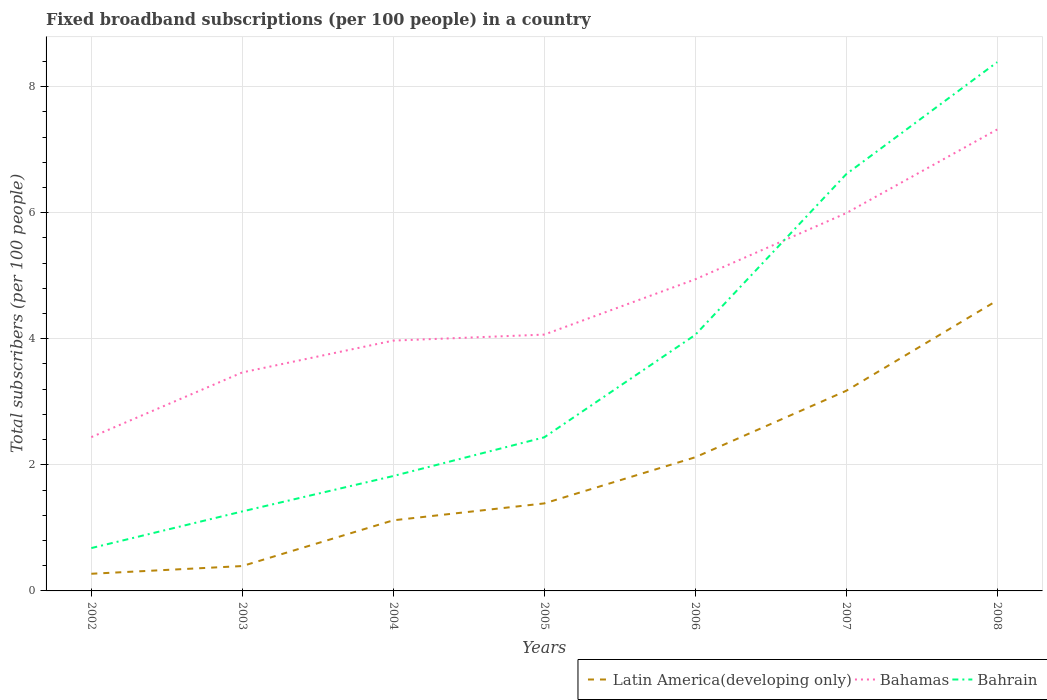Does the line corresponding to Bahrain intersect with the line corresponding to Latin America(developing only)?
Make the answer very short. No. Is the number of lines equal to the number of legend labels?
Keep it short and to the point. Yes. Across all years, what is the maximum number of broadband subscriptions in Bahamas?
Your response must be concise. 2.44. In which year was the number of broadband subscriptions in Bahamas maximum?
Your answer should be very brief. 2002. What is the total number of broadband subscriptions in Bahrain in the graph?
Keep it short and to the point. -5.95. What is the difference between the highest and the second highest number of broadband subscriptions in Latin America(developing only)?
Provide a short and direct response. 4.34. What is the difference between the highest and the lowest number of broadband subscriptions in Latin America(developing only)?
Offer a very short reply. 3. How many lines are there?
Your answer should be compact. 3. Are the values on the major ticks of Y-axis written in scientific E-notation?
Provide a succinct answer. No. Does the graph contain grids?
Offer a very short reply. Yes. How many legend labels are there?
Provide a short and direct response. 3. How are the legend labels stacked?
Keep it short and to the point. Horizontal. What is the title of the graph?
Give a very brief answer. Fixed broadband subscriptions (per 100 people) in a country. Does "Korea (Democratic)" appear as one of the legend labels in the graph?
Make the answer very short. No. What is the label or title of the Y-axis?
Your answer should be compact. Total subscribers (per 100 people). What is the Total subscribers (per 100 people) in Latin America(developing only) in 2002?
Make the answer very short. 0.27. What is the Total subscribers (per 100 people) of Bahamas in 2002?
Provide a succinct answer. 2.44. What is the Total subscribers (per 100 people) of Bahrain in 2002?
Your response must be concise. 0.68. What is the Total subscribers (per 100 people) in Latin America(developing only) in 2003?
Your answer should be very brief. 0.39. What is the Total subscribers (per 100 people) of Bahamas in 2003?
Your response must be concise. 3.47. What is the Total subscribers (per 100 people) of Bahrain in 2003?
Ensure brevity in your answer.  1.26. What is the Total subscribers (per 100 people) of Latin America(developing only) in 2004?
Offer a terse response. 1.12. What is the Total subscribers (per 100 people) in Bahamas in 2004?
Ensure brevity in your answer.  3.97. What is the Total subscribers (per 100 people) in Bahrain in 2004?
Keep it short and to the point. 1.82. What is the Total subscribers (per 100 people) in Latin America(developing only) in 2005?
Offer a very short reply. 1.39. What is the Total subscribers (per 100 people) of Bahamas in 2005?
Your answer should be compact. 4.07. What is the Total subscribers (per 100 people) of Bahrain in 2005?
Give a very brief answer. 2.44. What is the Total subscribers (per 100 people) of Latin America(developing only) in 2006?
Ensure brevity in your answer.  2.12. What is the Total subscribers (per 100 people) in Bahamas in 2006?
Your answer should be compact. 4.94. What is the Total subscribers (per 100 people) in Bahrain in 2006?
Your answer should be compact. 4.06. What is the Total subscribers (per 100 people) in Latin America(developing only) in 2007?
Provide a short and direct response. 3.17. What is the Total subscribers (per 100 people) of Bahamas in 2007?
Your response must be concise. 5.99. What is the Total subscribers (per 100 people) of Bahrain in 2007?
Offer a very short reply. 6.61. What is the Total subscribers (per 100 people) of Latin America(developing only) in 2008?
Keep it short and to the point. 4.61. What is the Total subscribers (per 100 people) of Bahamas in 2008?
Your answer should be very brief. 7.32. What is the Total subscribers (per 100 people) in Bahrain in 2008?
Your response must be concise. 8.39. Across all years, what is the maximum Total subscribers (per 100 people) in Latin America(developing only)?
Keep it short and to the point. 4.61. Across all years, what is the maximum Total subscribers (per 100 people) of Bahamas?
Keep it short and to the point. 7.32. Across all years, what is the maximum Total subscribers (per 100 people) of Bahrain?
Your answer should be very brief. 8.39. Across all years, what is the minimum Total subscribers (per 100 people) of Latin America(developing only)?
Ensure brevity in your answer.  0.27. Across all years, what is the minimum Total subscribers (per 100 people) in Bahamas?
Your response must be concise. 2.44. Across all years, what is the minimum Total subscribers (per 100 people) in Bahrain?
Offer a terse response. 0.68. What is the total Total subscribers (per 100 people) of Latin America(developing only) in the graph?
Give a very brief answer. 13.08. What is the total Total subscribers (per 100 people) in Bahamas in the graph?
Your answer should be compact. 32.2. What is the total Total subscribers (per 100 people) in Bahrain in the graph?
Give a very brief answer. 25.26. What is the difference between the Total subscribers (per 100 people) in Latin America(developing only) in 2002 and that in 2003?
Your response must be concise. -0.12. What is the difference between the Total subscribers (per 100 people) of Bahamas in 2002 and that in 2003?
Offer a terse response. -1.03. What is the difference between the Total subscribers (per 100 people) in Bahrain in 2002 and that in 2003?
Make the answer very short. -0.58. What is the difference between the Total subscribers (per 100 people) in Latin America(developing only) in 2002 and that in 2004?
Your answer should be compact. -0.85. What is the difference between the Total subscribers (per 100 people) in Bahamas in 2002 and that in 2004?
Your answer should be very brief. -1.53. What is the difference between the Total subscribers (per 100 people) of Bahrain in 2002 and that in 2004?
Your answer should be very brief. -1.14. What is the difference between the Total subscribers (per 100 people) in Latin America(developing only) in 2002 and that in 2005?
Your response must be concise. -1.12. What is the difference between the Total subscribers (per 100 people) of Bahamas in 2002 and that in 2005?
Make the answer very short. -1.63. What is the difference between the Total subscribers (per 100 people) in Bahrain in 2002 and that in 2005?
Make the answer very short. -1.76. What is the difference between the Total subscribers (per 100 people) of Latin America(developing only) in 2002 and that in 2006?
Your answer should be very brief. -1.85. What is the difference between the Total subscribers (per 100 people) in Bahamas in 2002 and that in 2006?
Ensure brevity in your answer.  -2.5. What is the difference between the Total subscribers (per 100 people) in Bahrain in 2002 and that in 2006?
Provide a short and direct response. -3.38. What is the difference between the Total subscribers (per 100 people) in Latin America(developing only) in 2002 and that in 2007?
Your answer should be compact. -2.9. What is the difference between the Total subscribers (per 100 people) of Bahamas in 2002 and that in 2007?
Make the answer very short. -3.55. What is the difference between the Total subscribers (per 100 people) in Bahrain in 2002 and that in 2007?
Your answer should be compact. -5.93. What is the difference between the Total subscribers (per 100 people) in Latin America(developing only) in 2002 and that in 2008?
Provide a succinct answer. -4.34. What is the difference between the Total subscribers (per 100 people) in Bahamas in 2002 and that in 2008?
Your answer should be compact. -4.88. What is the difference between the Total subscribers (per 100 people) of Bahrain in 2002 and that in 2008?
Offer a very short reply. -7.71. What is the difference between the Total subscribers (per 100 people) of Latin America(developing only) in 2003 and that in 2004?
Offer a terse response. -0.73. What is the difference between the Total subscribers (per 100 people) of Bahamas in 2003 and that in 2004?
Make the answer very short. -0.5. What is the difference between the Total subscribers (per 100 people) of Bahrain in 2003 and that in 2004?
Ensure brevity in your answer.  -0.56. What is the difference between the Total subscribers (per 100 people) of Latin America(developing only) in 2003 and that in 2005?
Offer a very short reply. -0.99. What is the difference between the Total subscribers (per 100 people) of Bahamas in 2003 and that in 2005?
Make the answer very short. -0.6. What is the difference between the Total subscribers (per 100 people) in Bahrain in 2003 and that in 2005?
Ensure brevity in your answer.  -1.18. What is the difference between the Total subscribers (per 100 people) of Latin America(developing only) in 2003 and that in 2006?
Your answer should be very brief. -1.73. What is the difference between the Total subscribers (per 100 people) of Bahamas in 2003 and that in 2006?
Provide a short and direct response. -1.48. What is the difference between the Total subscribers (per 100 people) of Bahrain in 2003 and that in 2006?
Offer a terse response. -2.8. What is the difference between the Total subscribers (per 100 people) of Latin America(developing only) in 2003 and that in 2007?
Your answer should be compact. -2.78. What is the difference between the Total subscribers (per 100 people) in Bahamas in 2003 and that in 2007?
Offer a terse response. -2.53. What is the difference between the Total subscribers (per 100 people) of Bahrain in 2003 and that in 2007?
Provide a short and direct response. -5.35. What is the difference between the Total subscribers (per 100 people) in Latin America(developing only) in 2003 and that in 2008?
Offer a terse response. -4.21. What is the difference between the Total subscribers (per 100 people) of Bahamas in 2003 and that in 2008?
Keep it short and to the point. -3.85. What is the difference between the Total subscribers (per 100 people) in Bahrain in 2003 and that in 2008?
Provide a short and direct response. -7.13. What is the difference between the Total subscribers (per 100 people) in Latin America(developing only) in 2004 and that in 2005?
Ensure brevity in your answer.  -0.27. What is the difference between the Total subscribers (per 100 people) of Bahamas in 2004 and that in 2005?
Your answer should be very brief. -0.1. What is the difference between the Total subscribers (per 100 people) in Bahrain in 2004 and that in 2005?
Provide a succinct answer. -0.61. What is the difference between the Total subscribers (per 100 people) in Latin America(developing only) in 2004 and that in 2006?
Ensure brevity in your answer.  -1. What is the difference between the Total subscribers (per 100 people) in Bahamas in 2004 and that in 2006?
Your answer should be very brief. -0.97. What is the difference between the Total subscribers (per 100 people) of Bahrain in 2004 and that in 2006?
Your answer should be very brief. -2.24. What is the difference between the Total subscribers (per 100 people) of Latin America(developing only) in 2004 and that in 2007?
Offer a very short reply. -2.05. What is the difference between the Total subscribers (per 100 people) in Bahamas in 2004 and that in 2007?
Make the answer very short. -2.02. What is the difference between the Total subscribers (per 100 people) in Bahrain in 2004 and that in 2007?
Your answer should be very brief. -4.79. What is the difference between the Total subscribers (per 100 people) in Latin America(developing only) in 2004 and that in 2008?
Provide a short and direct response. -3.49. What is the difference between the Total subscribers (per 100 people) in Bahamas in 2004 and that in 2008?
Your answer should be very brief. -3.35. What is the difference between the Total subscribers (per 100 people) of Bahrain in 2004 and that in 2008?
Your response must be concise. -6.57. What is the difference between the Total subscribers (per 100 people) in Latin America(developing only) in 2005 and that in 2006?
Your answer should be compact. -0.73. What is the difference between the Total subscribers (per 100 people) of Bahamas in 2005 and that in 2006?
Provide a succinct answer. -0.88. What is the difference between the Total subscribers (per 100 people) of Bahrain in 2005 and that in 2006?
Offer a terse response. -1.63. What is the difference between the Total subscribers (per 100 people) in Latin America(developing only) in 2005 and that in 2007?
Offer a terse response. -1.79. What is the difference between the Total subscribers (per 100 people) in Bahamas in 2005 and that in 2007?
Provide a short and direct response. -1.93. What is the difference between the Total subscribers (per 100 people) of Bahrain in 2005 and that in 2007?
Give a very brief answer. -4.17. What is the difference between the Total subscribers (per 100 people) in Latin America(developing only) in 2005 and that in 2008?
Offer a terse response. -3.22. What is the difference between the Total subscribers (per 100 people) in Bahamas in 2005 and that in 2008?
Keep it short and to the point. -3.25. What is the difference between the Total subscribers (per 100 people) of Bahrain in 2005 and that in 2008?
Provide a succinct answer. -5.95. What is the difference between the Total subscribers (per 100 people) of Latin America(developing only) in 2006 and that in 2007?
Provide a succinct answer. -1.05. What is the difference between the Total subscribers (per 100 people) of Bahamas in 2006 and that in 2007?
Your answer should be very brief. -1.05. What is the difference between the Total subscribers (per 100 people) in Bahrain in 2006 and that in 2007?
Your answer should be compact. -2.55. What is the difference between the Total subscribers (per 100 people) of Latin America(developing only) in 2006 and that in 2008?
Offer a very short reply. -2.49. What is the difference between the Total subscribers (per 100 people) of Bahamas in 2006 and that in 2008?
Give a very brief answer. -2.38. What is the difference between the Total subscribers (per 100 people) of Bahrain in 2006 and that in 2008?
Your response must be concise. -4.33. What is the difference between the Total subscribers (per 100 people) in Latin America(developing only) in 2007 and that in 2008?
Offer a terse response. -1.43. What is the difference between the Total subscribers (per 100 people) in Bahamas in 2007 and that in 2008?
Provide a succinct answer. -1.33. What is the difference between the Total subscribers (per 100 people) in Bahrain in 2007 and that in 2008?
Offer a terse response. -1.78. What is the difference between the Total subscribers (per 100 people) of Latin America(developing only) in 2002 and the Total subscribers (per 100 people) of Bahamas in 2003?
Provide a succinct answer. -3.19. What is the difference between the Total subscribers (per 100 people) in Latin America(developing only) in 2002 and the Total subscribers (per 100 people) in Bahrain in 2003?
Keep it short and to the point. -0.99. What is the difference between the Total subscribers (per 100 people) in Bahamas in 2002 and the Total subscribers (per 100 people) in Bahrain in 2003?
Give a very brief answer. 1.18. What is the difference between the Total subscribers (per 100 people) of Latin America(developing only) in 2002 and the Total subscribers (per 100 people) of Bahamas in 2004?
Offer a very short reply. -3.7. What is the difference between the Total subscribers (per 100 people) in Latin America(developing only) in 2002 and the Total subscribers (per 100 people) in Bahrain in 2004?
Offer a very short reply. -1.55. What is the difference between the Total subscribers (per 100 people) in Bahamas in 2002 and the Total subscribers (per 100 people) in Bahrain in 2004?
Keep it short and to the point. 0.62. What is the difference between the Total subscribers (per 100 people) in Latin America(developing only) in 2002 and the Total subscribers (per 100 people) in Bahamas in 2005?
Offer a very short reply. -3.79. What is the difference between the Total subscribers (per 100 people) of Latin America(developing only) in 2002 and the Total subscribers (per 100 people) of Bahrain in 2005?
Your response must be concise. -2.16. What is the difference between the Total subscribers (per 100 people) in Bahamas in 2002 and the Total subscribers (per 100 people) in Bahrain in 2005?
Your answer should be very brief. 0. What is the difference between the Total subscribers (per 100 people) in Latin America(developing only) in 2002 and the Total subscribers (per 100 people) in Bahamas in 2006?
Your answer should be very brief. -4.67. What is the difference between the Total subscribers (per 100 people) of Latin America(developing only) in 2002 and the Total subscribers (per 100 people) of Bahrain in 2006?
Give a very brief answer. -3.79. What is the difference between the Total subscribers (per 100 people) of Bahamas in 2002 and the Total subscribers (per 100 people) of Bahrain in 2006?
Offer a very short reply. -1.62. What is the difference between the Total subscribers (per 100 people) in Latin America(developing only) in 2002 and the Total subscribers (per 100 people) in Bahamas in 2007?
Offer a very short reply. -5.72. What is the difference between the Total subscribers (per 100 people) of Latin America(developing only) in 2002 and the Total subscribers (per 100 people) of Bahrain in 2007?
Offer a very short reply. -6.34. What is the difference between the Total subscribers (per 100 people) in Bahamas in 2002 and the Total subscribers (per 100 people) in Bahrain in 2007?
Keep it short and to the point. -4.17. What is the difference between the Total subscribers (per 100 people) of Latin America(developing only) in 2002 and the Total subscribers (per 100 people) of Bahamas in 2008?
Offer a terse response. -7.05. What is the difference between the Total subscribers (per 100 people) of Latin America(developing only) in 2002 and the Total subscribers (per 100 people) of Bahrain in 2008?
Your answer should be very brief. -8.12. What is the difference between the Total subscribers (per 100 people) in Bahamas in 2002 and the Total subscribers (per 100 people) in Bahrain in 2008?
Provide a succinct answer. -5.95. What is the difference between the Total subscribers (per 100 people) of Latin America(developing only) in 2003 and the Total subscribers (per 100 people) of Bahamas in 2004?
Provide a short and direct response. -3.58. What is the difference between the Total subscribers (per 100 people) of Latin America(developing only) in 2003 and the Total subscribers (per 100 people) of Bahrain in 2004?
Your answer should be very brief. -1.43. What is the difference between the Total subscribers (per 100 people) in Bahamas in 2003 and the Total subscribers (per 100 people) in Bahrain in 2004?
Provide a short and direct response. 1.64. What is the difference between the Total subscribers (per 100 people) of Latin America(developing only) in 2003 and the Total subscribers (per 100 people) of Bahamas in 2005?
Provide a short and direct response. -3.67. What is the difference between the Total subscribers (per 100 people) in Latin America(developing only) in 2003 and the Total subscribers (per 100 people) in Bahrain in 2005?
Provide a short and direct response. -2.04. What is the difference between the Total subscribers (per 100 people) of Bahamas in 2003 and the Total subscribers (per 100 people) of Bahrain in 2005?
Your response must be concise. 1.03. What is the difference between the Total subscribers (per 100 people) of Latin America(developing only) in 2003 and the Total subscribers (per 100 people) of Bahamas in 2006?
Make the answer very short. -4.55. What is the difference between the Total subscribers (per 100 people) in Latin America(developing only) in 2003 and the Total subscribers (per 100 people) in Bahrain in 2006?
Your response must be concise. -3.67. What is the difference between the Total subscribers (per 100 people) in Bahamas in 2003 and the Total subscribers (per 100 people) in Bahrain in 2006?
Keep it short and to the point. -0.6. What is the difference between the Total subscribers (per 100 people) of Latin America(developing only) in 2003 and the Total subscribers (per 100 people) of Bahamas in 2007?
Keep it short and to the point. -5.6. What is the difference between the Total subscribers (per 100 people) of Latin America(developing only) in 2003 and the Total subscribers (per 100 people) of Bahrain in 2007?
Provide a succinct answer. -6.22. What is the difference between the Total subscribers (per 100 people) in Bahamas in 2003 and the Total subscribers (per 100 people) in Bahrain in 2007?
Your answer should be very brief. -3.14. What is the difference between the Total subscribers (per 100 people) of Latin America(developing only) in 2003 and the Total subscribers (per 100 people) of Bahamas in 2008?
Offer a terse response. -6.93. What is the difference between the Total subscribers (per 100 people) in Latin America(developing only) in 2003 and the Total subscribers (per 100 people) in Bahrain in 2008?
Offer a terse response. -7.99. What is the difference between the Total subscribers (per 100 people) of Bahamas in 2003 and the Total subscribers (per 100 people) of Bahrain in 2008?
Offer a very short reply. -4.92. What is the difference between the Total subscribers (per 100 people) in Latin America(developing only) in 2004 and the Total subscribers (per 100 people) in Bahamas in 2005?
Offer a very short reply. -2.95. What is the difference between the Total subscribers (per 100 people) in Latin America(developing only) in 2004 and the Total subscribers (per 100 people) in Bahrain in 2005?
Keep it short and to the point. -1.32. What is the difference between the Total subscribers (per 100 people) of Bahamas in 2004 and the Total subscribers (per 100 people) of Bahrain in 2005?
Provide a succinct answer. 1.53. What is the difference between the Total subscribers (per 100 people) of Latin America(developing only) in 2004 and the Total subscribers (per 100 people) of Bahamas in 2006?
Offer a very short reply. -3.82. What is the difference between the Total subscribers (per 100 people) of Latin America(developing only) in 2004 and the Total subscribers (per 100 people) of Bahrain in 2006?
Keep it short and to the point. -2.94. What is the difference between the Total subscribers (per 100 people) of Bahamas in 2004 and the Total subscribers (per 100 people) of Bahrain in 2006?
Keep it short and to the point. -0.09. What is the difference between the Total subscribers (per 100 people) of Latin America(developing only) in 2004 and the Total subscribers (per 100 people) of Bahamas in 2007?
Provide a succinct answer. -4.87. What is the difference between the Total subscribers (per 100 people) of Latin America(developing only) in 2004 and the Total subscribers (per 100 people) of Bahrain in 2007?
Provide a short and direct response. -5.49. What is the difference between the Total subscribers (per 100 people) of Bahamas in 2004 and the Total subscribers (per 100 people) of Bahrain in 2007?
Your answer should be very brief. -2.64. What is the difference between the Total subscribers (per 100 people) in Latin America(developing only) in 2004 and the Total subscribers (per 100 people) in Bahamas in 2008?
Your answer should be compact. -6.2. What is the difference between the Total subscribers (per 100 people) of Latin America(developing only) in 2004 and the Total subscribers (per 100 people) of Bahrain in 2008?
Offer a very short reply. -7.27. What is the difference between the Total subscribers (per 100 people) in Bahamas in 2004 and the Total subscribers (per 100 people) in Bahrain in 2008?
Offer a terse response. -4.42. What is the difference between the Total subscribers (per 100 people) of Latin America(developing only) in 2005 and the Total subscribers (per 100 people) of Bahamas in 2006?
Your response must be concise. -3.56. What is the difference between the Total subscribers (per 100 people) of Latin America(developing only) in 2005 and the Total subscribers (per 100 people) of Bahrain in 2006?
Your answer should be compact. -2.67. What is the difference between the Total subscribers (per 100 people) of Bahamas in 2005 and the Total subscribers (per 100 people) of Bahrain in 2006?
Your answer should be compact. 0. What is the difference between the Total subscribers (per 100 people) of Latin America(developing only) in 2005 and the Total subscribers (per 100 people) of Bahamas in 2007?
Your response must be concise. -4.61. What is the difference between the Total subscribers (per 100 people) of Latin America(developing only) in 2005 and the Total subscribers (per 100 people) of Bahrain in 2007?
Keep it short and to the point. -5.22. What is the difference between the Total subscribers (per 100 people) of Bahamas in 2005 and the Total subscribers (per 100 people) of Bahrain in 2007?
Offer a terse response. -2.54. What is the difference between the Total subscribers (per 100 people) of Latin America(developing only) in 2005 and the Total subscribers (per 100 people) of Bahamas in 2008?
Your response must be concise. -5.93. What is the difference between the Total subscribers (per 100 people) of Latin America(developing only) in 2005 and the Total subscribers (per 100 people) of Bahrain in 2008?
Ensure brevity in your answer.  -7. What is the difference between the Total subscribers (per 100 people) of Bahamas in 2005 and the Total subscribers (per 100 people) of Bahrain in 2008?
Provide a succinct answer. -4.32. What is the difference between the Total subscribers (per 100 people) in Latin America(developing only) in 2006 and the Total subscribers (per 100 people) in Bahamas in 2007?
Provide a succinct answer. -3.87. What is the difference between the Total subscribers (per 100 people) in Latin America(developing only) in 2006 and the Total subscribers (per 100 people) in Bahrain in 2007?
Make the answer very short. -4.49. What is the difference between the Total subscribers (per 100 people) of Bahamas in 2006 and the Total subscribers (per 100 people) of Bahrain in 2007?
Make the answer very short. -1.67. What is the difference between the Total subscribers (per 100 people) in Latin America(developing only) in 2006 and the Total subscribers (per 100 people) in Bahamas in 2008?
Your answer should be compact. -5.2. What is the difference between the Total subscribers (per 100 people) of Latin America(developing only) in 2006 and the Total subscribers (per 100 people) of Bahrain in 2008?
Ensure brevity in your answer.  -6.27. What is the difference between the Total subscribers (per 100 people) of Bahamas in 2006 and the Total subscribers (per 100 people) of Bahrain in 2008?
Provide a succinct answer. -3.45. What is the difference between the Total subscribers (per 100 people) of Latin America(developing only) in 2007 and the Total subscribers (per 100 people) of Bahamas in 2008?
Provide a short and direct response. -4.15. What is the difference between the Total subscribers (per 100 people) in Latin America(developing only) in 2007 and the Total subscribers (per 100 people) in Bahrain in 2008?
Give a very brief answer. -5.21. What is the difference between the Total subscribers (per 100 people) in Bahamas in 2007 and the Total subscribers (per 100 people) in Bahrain in 2008?
Make the answer very short. -2.4. What is the average Total subscribers (per 100 people) in Latin America(developing only) per year?
Ensure brevity in your answer.  1.87. What is the average Total subscribers (per 100 people) of Bahamas per year?
Offer a terse response. 4.6. What is the average Total subscribers (per 100 people) in Bahrain per year?
Your answer should be very brief. 3.61. In the year 2002, what is the difference between the Total subscribers (per 100 people) of Latin America(developing only) and Total subscribers (per 100 people) of Bahamas?
Keep it short and to the point. -2.17. In the year 2002, what is the difference between the Total subscribers (per 100 people) of Latin America(developing only) and Total subscribers (per 100 people) of Bahrain?
Provide a succinct answer. -0.41. In the year 2002, what is the difference between the Total subscribers (per 100 people) of Bahamas and Total subscribers (per 100 people) of Bahrain?
Provide a succinct answer. 1.76. In the year 2003, what is the difference between the Total subscribers (per 100 people) of Latin America(developing only) and Total subscribers (per 100 people) of Bahamas?
Give a very brief answer. -3.07. In the year 2003, what is the difference between the Total subscribers (per 100 people) of Latin America(developing only) and Total subscribers (per 100 people) of Bahrain?
Give a very brief answer. -0.87. In the year 2003, what is the difference between the Total subscribers (per 100 people) of Bahamas and Total subscribers (per 100 people) of Bahrain?
Provide a short and direct response. 2.21. In the year 2004, what is the difference between the Total subscribers (per 100 people) of Latin America(developing only) and Total subscribers (per 100 people) of Bahamas?
Your answer should be very brief. -2.85. In the year 2004, what is the difference between the Total subscribers (per 100 people) of Latin America(developing only) and Total subscribers (per 100 people) of Bahrain?
Give a very brief answer. -0.7. In the year 2004, what is the difference between the Total subscribers (per 100 people) of Bahamas and Total subscribers (per 100 people) of Bahrain?
Provide a short and direct response. 2.15. In the year 2005, what is the difference between the Total subscribers (per 100 people) in Latin America(developing only) and Total subscribers (per 100 people) in Bahamas?
Give a very brief answer. -2.68. In the year 2005, what is the difference between the Total subscribers (per 100 people) in Latin America(developing only) and Total subscribers (per 100 people) in Bahrain?
Make the answer very short. -1.05. In the year 2005, what is the difference between the Total subscribers (per 100 people) of Bahamas and Total subscribers (per 100 people) of Bahrain?
Provide a short and direct response. 1.63. In the year 2006, what is the difference between the Total subscribers (per 100 people) of Latin America(developing only) and Total subscribers (per 100 people) of Bahamas?
Offer a terse response. -2.82. In the year 2006, what is the difference between the Total subscribers (per 100 people) in Latin America(developing only) and Total subscribers (per 100 people) in Bahrain?
Make the answer very short. -1.94. In the year 2006, what is the difference between the Total subscribers (per 100 people) in Bahamas and Total subscribers (per 100 people) in Bahrain?
Provide a short and direct response. 0.88. In the year 2007, what is the difference between the Total subscribers (per 100 people) in Latin America(developing only) and Total subscribers (per 100 people) in Bahamas?
Offer a terse response. -2.82. In the year 2007, what is the difference between the Total subscribers (per 100 people) in Latin America(developing only) and Total subscribers (per 100 people) in Bahrain?
Keep it short and to the point. -3.44. In the year 2007, what is the difference between the Total subscribers (per 100 people) of Bahamas and Total subscribers (per 100 people) of Bahrain?
Provide a short and direct response. -0.62. In the year 2008, what is the difference between the Total subscribers (per 100 people) in Latin America(developing only) and Total subscribers (per 100 people) in Bahamas?
Your response must be concise. -2.71. In the year 2008, what is the difference between the Total subscribers (per 100 people) of Latin America(developing only) and Total subscribers (per 100 people) of Bahrain?
Your answer should be very brief. -3.78. In the year 2008, what is the difference between the Total subscribers (per 100 people) in Bahamas and Total subscribers (per 100 people) in Bahrain?
Your answer should be compact. -1.07. What is the ratio of the Total subscribers (per 100 people) in Latin America(developing only) in 2002 to that in 2003?
Ensure brevity in your answer.  0.69. What is the ratio of the Total subscribers (per 100 people) in Bahamas in 2002 to that in 2003?
Provide a short and direct response. 0.7. What is the ratio of the Total subscribers (per 100 people) in Bahrain in 2002 to that in 2003?
Your answer should be compact. 0.54. What is the ratio of the Total subscribers (per 100 people) of Latin America(developing only) in 2002 to that in 2004?
Provide a short and direct response. 0.24. What is the ratio of the Total subscribers (per 100 people) in Bahamas in 2002 to that in 2004?
Offer a very short reply. 0.61. What is the ratio of the Total subscribers (per 100 people) in Bahrain in 2002 to that in 2004?
Offer a terse response. 0.37. What is the ratio of the Total subscribers (per 100 people) of Latin America(developing only) in 2002 to that in 2005?
Provide a short and direct response. 0.2. What is the ratio of the Total subscribers (per 100 people) of Bahamas in 2002 to that in 2005?
Your response must be concise. 0.6. What is the ratio of the Total subscribers (per 100 people) of Bahrain in 2002 to that in 2005?
Ensure brevity in your answer.  0.28. What is the ratio of the Total subscribers (per 100 people) in Latin America(developing only) in 2002 to that in 2006?
Offer a very short reply. 0.13. What is the ratio of the Total subscribers (per 100 people) in Bahamas in 2002 to that in 2006?
Provide a short and direct response. 0.49. What is the ratio of the Total subscribers (per 100 people) in Bahrain in 2002 to that in 2006?
Ensure brevity in your answer.  0.17. What is the ratio of the Total subscribers (per 100 people) in Latin America(developing only) in 2002 to that in 2007?
Your answer should be compact. 0.09. What is the ratio of the Total subscribers (per 100 people) of Bahamas in 2002 to that in 2007?
Offer a terse response. 0.41. What is the ratio of the Total subscribers (per 100 people) in Bahrain in 2002 to that in 2007?
Keep it short and to the point. 0.1. What is the ratio of the Total subscribers (per 100 people) in Latin America(developing only) in 2002 to that in 2008?
Your response must be concise. 0.06. What is the ratio of the Total subscribers (per 100 people) of Bahrain in 2002 to that in 2008?
Offer a terse response. 0.08. What is the ratio of the Total subscribers (per 100 people) in Latin America(developing only) in 2003 to that in 2004?
Keep it short and to the point. 0.35. What is the ratio of the Total subscribers (per 100 people) of Bahamas in 2003 to that in 2004?
Your response must be concise. 0.87. What is the ratio of the Total subscribers (per 100 people) in Bahrain in 2003 to that in 2004?
Offer a terse response. 0.69. What is the ratio of the Total subscribers (per 100 people) in Latin America(developing only) in 2003 to that in 2005?
Your response must be concise. 0.28. What is the ratio of the Total subscribers (per 100 people) in Bahamas in 2003 to that in 2005?
Offer a terse response. 0.85. What is the ratio of the Total subscribers (per 100 people) of Bahrain in 2003 to that in 2005?
Your response must be concise. 0.52. What is the ratio of the Total subscribers (per 100 people) of Latin America(developing only) in 2003 to that in 2006?
Ensure brevity in your answer.  0.19. What is the ratio of the Total subscribers (per 100 people) of Bahamas in 2003 to that in 2006?
Make the answer very short. 0.7. What is the ratio of the Total subscribers (per 100 people) of Bahrain in 2003 to that in 2006?
Make the answer very short. 0.31. What is the ratio of the Total subscribers (per 100 people) of Latin America(developing only) in 2003 to that in 2007?
Give a very brief answer. 0.12. What is the ratio of the Total subscribers (per 100 people) in Bahamas in 2003 to that in 2007?
Keep it short and to the point. 0.58. What is the ratio of the Total subscribers (per 100 people) of Bahrain in 2003 to that in 2007?
Your answer should be very brief. 0.19. What is the ratio of the Total subscribers (per 100 people) in Latin America(developing only) in 2003 to that in 2008?
Offer a very short reply. 0.09. What is the ratio of the Total subscribers (per 100 people) of Bahamas in 2003 to that in 2008?
Your response must be concise. 0.47. What is the ratio of the Total subscribers (per 100 people) of Bahrain in 2003 to that in 2008?
Make the answer very short. 0.15. What is the ratio of the Total subscribers (per 100 people) of Latin America(developing only) in 2004 to that in 2005?
Make the answer very short. 0.81. What is the ratio of the Total subscribers (per 100 people) of Bahamas in 2004 to that in 2005?
Provide a succinct answer. 0.98. What is the ratio of the Total subscribers (per 100 people) in Bahrain in 2004 to that in 2005?
Provide a short and direct response. 0.75. What is the ratio of the Total subscribers (per 100 people) in Latin America(developing only) in 2004 to that in 2006?
Your response must be concise. 0.53. What is the ratio of the Total subscribers (per 100 people) of Bahamas in 2004 to that in 2006?
Offer a terse response. 0.8. What is the ratio of the Total subscribers (per 100 people) in Bahrain in 2004 to that in 2006?
Make the answer very short. 0.45. What is the ratio of the Total subscribers (per 100 people) in Latin America(developing only) in 2004 to that in 2007?
Make the answer very short. 0.35. What is the ratio of the Total subscribers (per 100 people) of Bahamas in 2004 to that in 2007?
Provide a short and direct response. 0.66. What is the ratio of the Total subscribers (per 100 people) in Bahrain in 2004 to that in 2007?
Provide a short and direct response. 0.28. What is the ratio of the Total subscribers (per 100 people) in Latin America(developing only) in 2004 to that in 2008?
Offer a terse response. 0.24. What is the ratio of the Total subscribers (per 100 people) of Bahamas in 2004 to that in 2008?
Give a very brief answer. 0.54. What is the ratio of the Total subscribers (per 100 people) in Bahrain in 2004 to that in 2008?
Provide a short and direct response. 0.22. What is the ratio of the Total subscribers (per 100 people) of Latin America(developing only) in 2005 to that in 2006?
Your answer should be very brief. 0.65. What is the ratio of the Total subscribers (per 100 people) of Bahamas in 2005 to that in 2006?
Ensure brevity in your answer.  0.82. What is the ratio of the Total subscribers (per 100 people) in Bahrain in 2005 to that in 2006?
Offer a very short reply. 0.6. What is the ratio of the Total subscribers (per 100 people) of Latin America(developing only) in 2005 to that in 2007?
Your answer should be compact. 0.44. What is the ratio of the Total subscribers (per 100 people) of Bahamas in 2005 to that in 2007?
Keep it short and to the point. 0.68. What is the ratio of the Total subscribers (per 100 people) in Bahrain in 2005 to that in 2007?
Your response must be concise. 0.37. What is the ratio of the Total subscribers (per 100 people) in Latin America(developing only) in 2005 to that in 2008?
Your answer should be compact. 0.3. What is the ratio of the Total subscribers (per 100 people) of Bahamas in 2005 to that in 2008?
Ensure brevity in your answer.  0.56. What is the ratio of the Total subscribers (per 100 people) of Bahrain in 2005 to that in 2008?
Give a very brief answer. 0.29. What is the ratio of the Total subscribers (per 100 people) of Latin America(developing only) in 2006 to that in 2007?
Your response must be concise. 0.67. What is the ratio of the Total subscribers (per 100 people) in Bahamas in 2006 to that in 2007?
Your answer should be compact. 0.82. What is the ratio of the Total subscribers (per 100 people) of Bahrain in 2006 to that in 2007?
Your response must be concise. 0.61. What is the ratio of the Total subscribers (per 100 people) in Latin America(developing only) in 2006 to that in 2008?
Keep it short and to the point. 0.46. What is the ratio of the Total subscribers (per 100 people) of Bahamas in 2006 to that in 2008?
Provide a succinct answer. 0.68. What is the ratio of the Total subscribers (per 100 people) in Bahrain in 2006 to that in 2008?
Give a very brief answer. 0.48. What is the ratio of the Total subscribers (per 100 people) of Latin America(developing only) in 2007 to that in 2008?
Provide a succinct answer. 0.69. What is the ratio of the Total subscribers (per 100 people) of Bahamas in 2007 to that in 2008?
Your response must be concise. 0.82. What is the ratio of the Total subscribers (per 100 people) of Bahrain in 2007 to that in 2008?
Ensure brevity in your answer.  0.79. What is the difference between the highest and the second highest Total subscribers (per 100 people) of Latin America(developing only)?
Offer a terse response. 1.43. What is the difference between the highest and the second highest Total subscribers (per 100 people) of Bahamas?
Provide a short and direct response. 1.33. What is the difference between the highest and the second highest Total subscribers (per 100 people) in Bahrain?
Ensure brevity in your answer.  1.78. What is the difference between the highest and the lowest Total subscribers (per 100 people) of Latin America(developing only)?
Offer a very short reply. 4.34. What is the difference between the highest and the lowest Total subscribers (per 100 people) of Bahamas?
Give a very brief answer. 4.88. What is the difference between the highest and the lowest Total subscribers (per 100 people) in Bahrain?
Your answer should be compact. 7.71. 